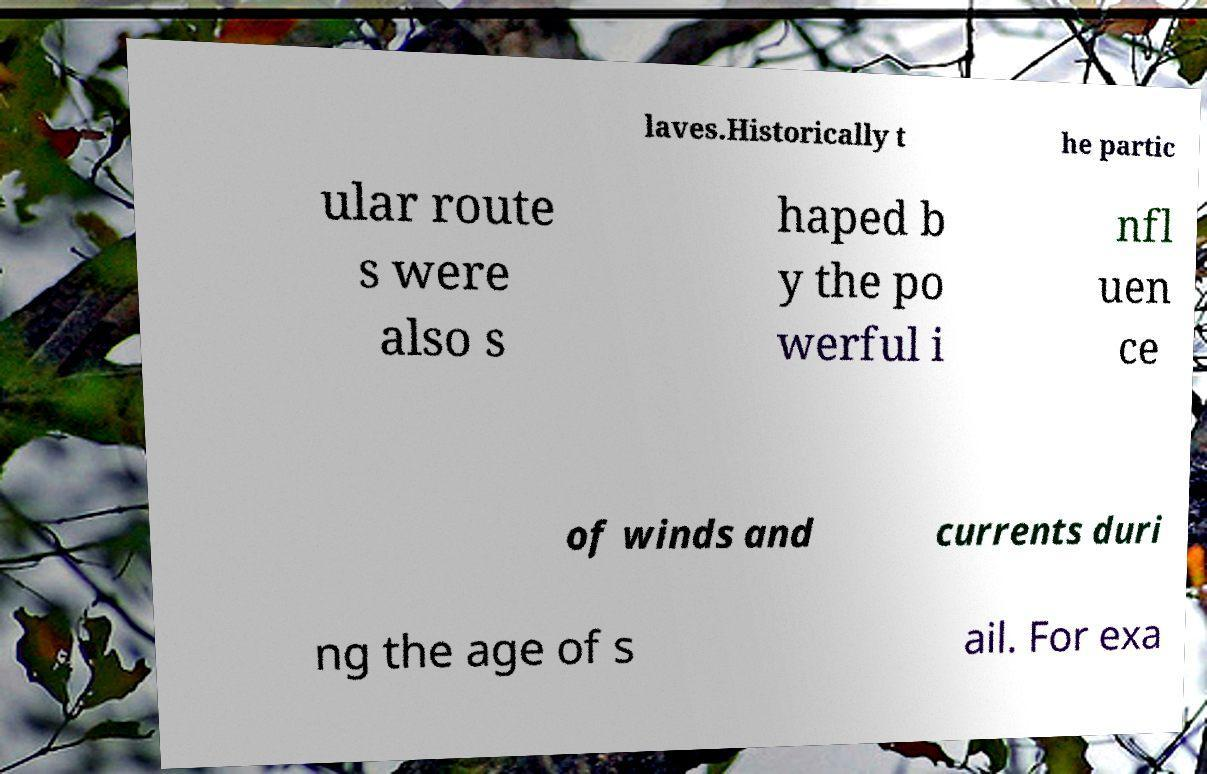For documentation purposes, I need the text within this image transcribed. Could you provide that? laves.Historically t he partic ular route s were also s haped b y the po werful i nfl uen ce of winds and currents duri ng the age of s ail. For exa 